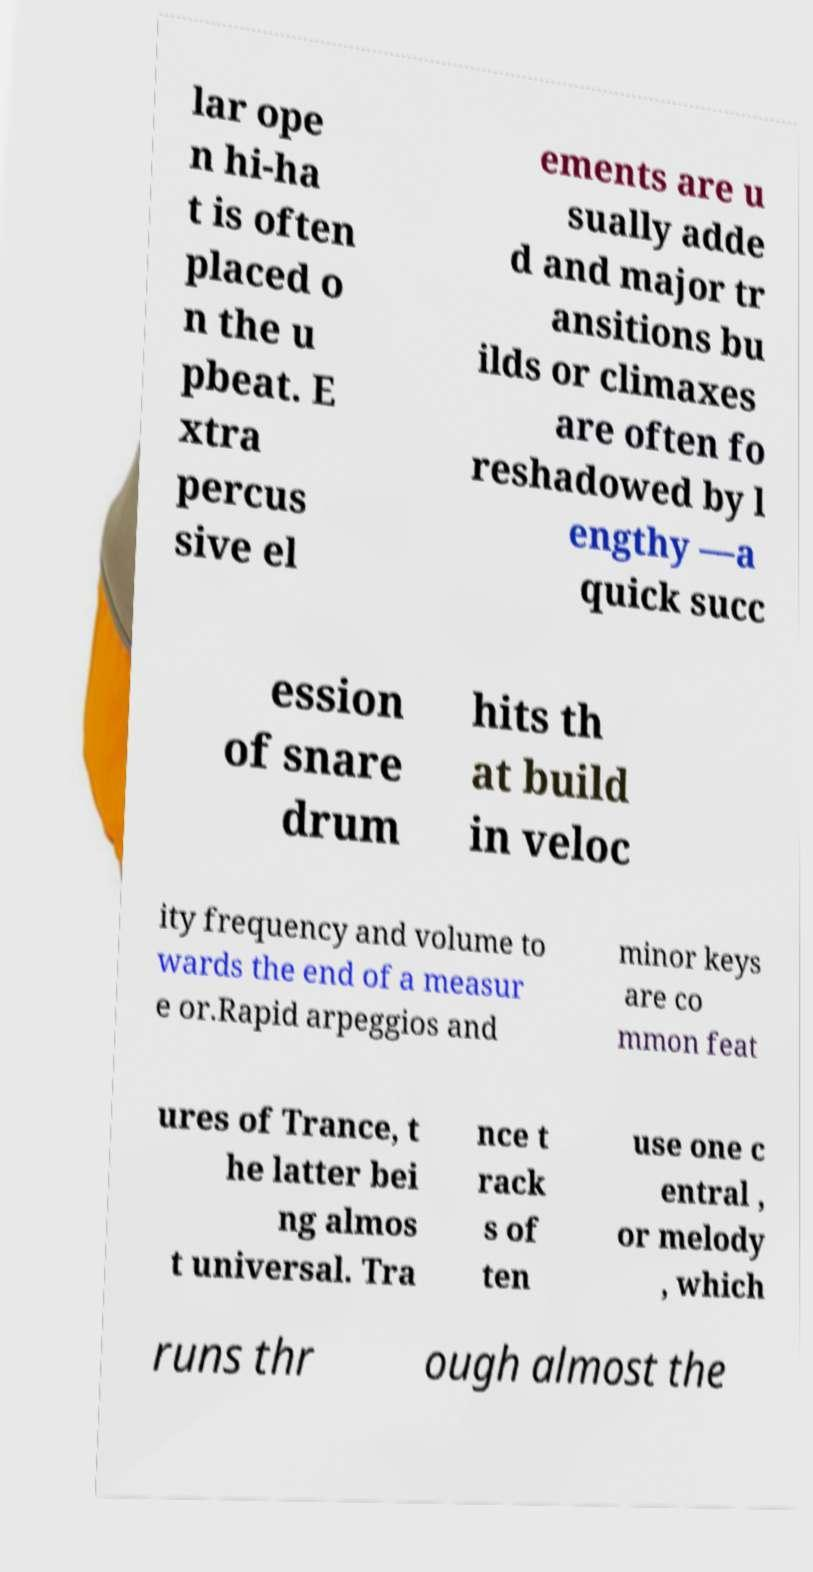There's text embedded in this image that I need extracted. Can you transcribe it verbatim? lar ope n hi-ha t is often placed o n the u pbeat. E xtra percus sive el ements are u sually adde d and major tr ansitions bu ilds or climaxes are often fo reshadowed by l engthy —a quick succ ession of snare drum hits th at build in veloc ity frequency and volume to wards the end of a measur e or.Rapid arpeggios and minor keys are co mmon feat ures of Trance, t he latter bei ng almos t universal. Tra nce t rack s of ten use one c entral , or melody , which runs thr ough almost the 